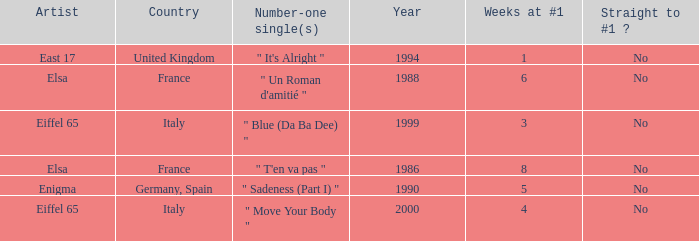How many years have a weeks at #1 value of exactly 8? 1.0. 